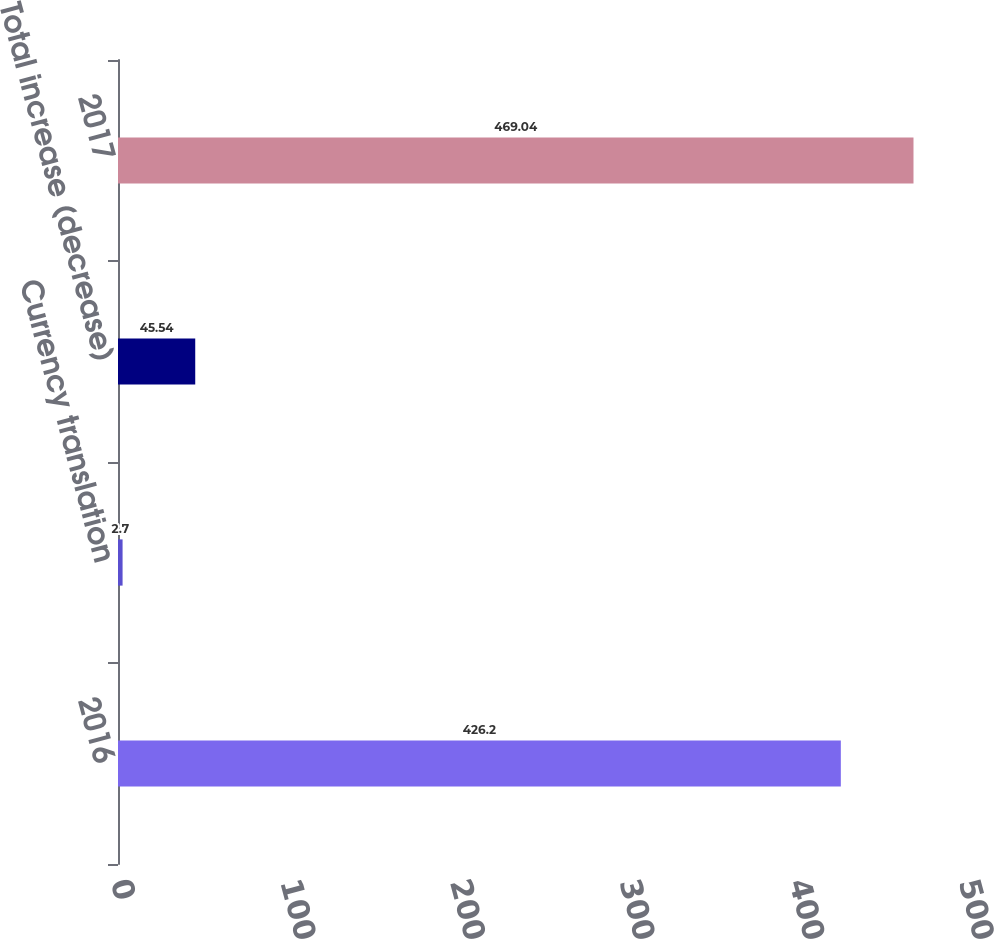<chart> <loc_0><loc_0><loc_500><loc_500><bar_chart><fcel>2016<fcel>Currency translation<fcel>Total increase (decrease)<fcel>2017<nl><fcel>426.2<fcel>2.7<fcel>45.54<fcel>469.04<nl></chart> 